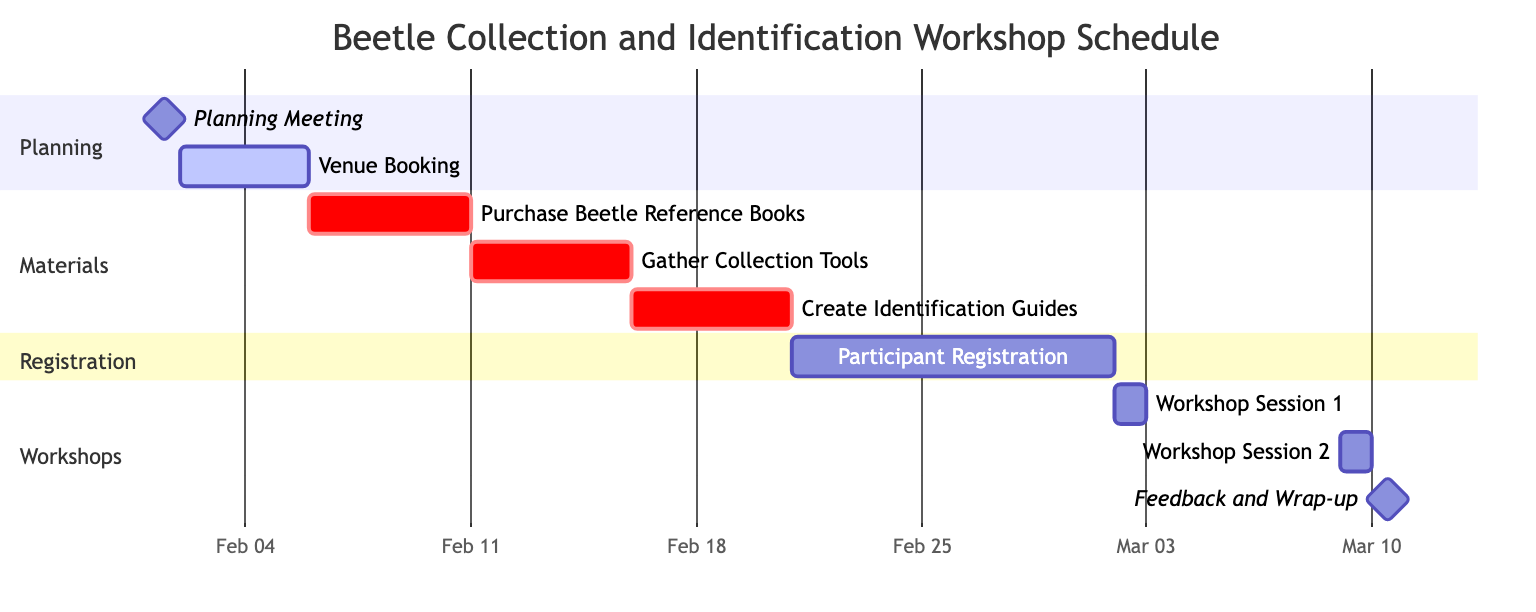What is the date of the Planning Meeting? The Planning Meeting is listed in the diagram with a start and end date of February 1, 2024. Thus, the specific date for this task is found directly in the timeline under the "Planning" section.
Answer: February 1, 2024 How many tasks are there in the Materials section? To find the number of tasks in the Materials section, we count the individual tasks listed under this section: Purchase Beetle Reference Books, Gather Collection Tools, and Create Identification Guides, which totals three tasks.
Answer: 3 What is the duration of the Participant Registration? The Participant Registration starts on February 21, 2024, and ends on March 1, 2024. To find the duration, we calculate the difference in days: from the 21st to the 1st is a total of 10 days.
Answer: 10 days When does Workshop Session 2 take place? Looking at the Workshops section, Workshop Session 2 is scheduled for March 9, 2024, as indicated by its start and end date being the same.
Answer: March 9, 2024 Which task overlaps with both Material Preparation and Participant Registration? By reviewing the timelines of these two sections, Material Preparation ends on February 20, 2024, and Participant Registration starts on February 21, 2024. No task overlaps, specifically because there is a day gap between them.
Answer: None How many days does the Venue Booking last? The Venue Booking task starts on February 2, 2024, and ends on February 5, 2024. Counting the inclusive days from the 2nd to the 5th gives a total of 4 days.
Answer: 4 days Which session is the last scheduled activity in the workshop? By assessing the timeline, the last scheduled activity in the workshop is Feedback and Wrap-up, which is scheduled for March 10, 2024. This is the last task listed under the Workshops section.
Answer: Feedback and Wrap-up What is the first task that requires critical materials preparation? The first critical task in the Materials section is Purchase Beetle Reference Books, beginning on February 6, 2024, which is the first task listed under this section.
Answer: Purchase Beetle Reference Books 